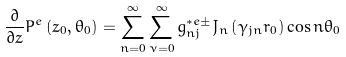Convert formula to latex. <formula><loc_0><loc_0><loc_500><loc_500>\frac { \partial } { \partial z } P ^ { e } \left ( z _ { 0 } , \theta _ { 0 } \right ) = \sum _ { n = 0 } ^ { \infty } \sum _ { \nu = 0 } ^ { \infty } g _ { n j } ^ { \ast e \pm } J _ { n } \left ( \gamma _ { j n } r _ { 0 } \right ) \cos n \theta _ { 0 }</formula> 